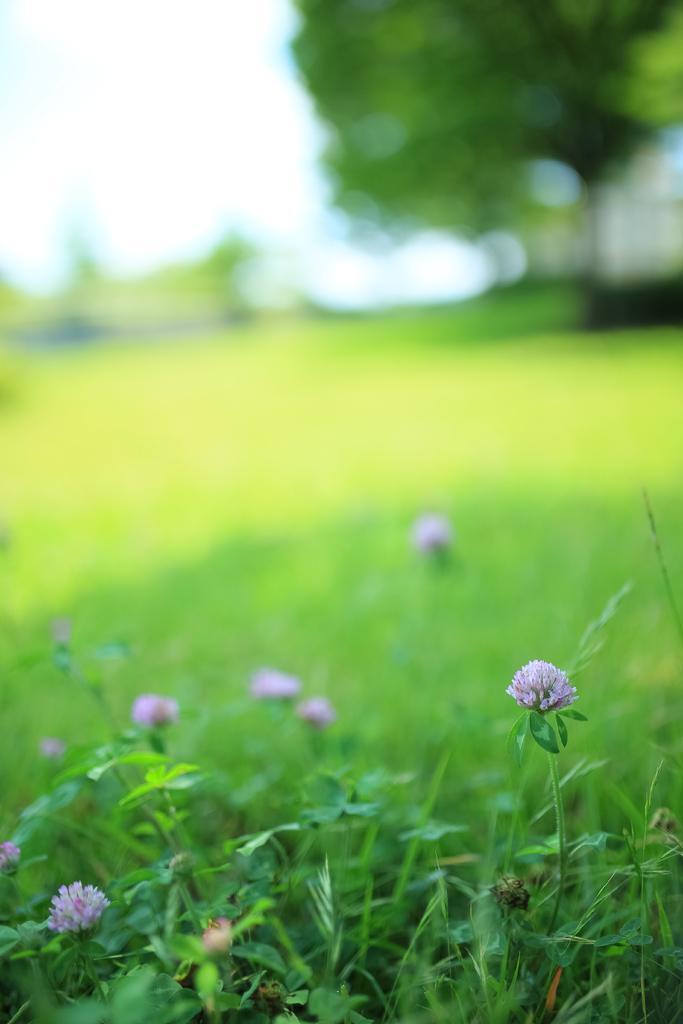Describe this image in one or two sentences. In this picture I can see flowers, there is grass, and there is blur background. 